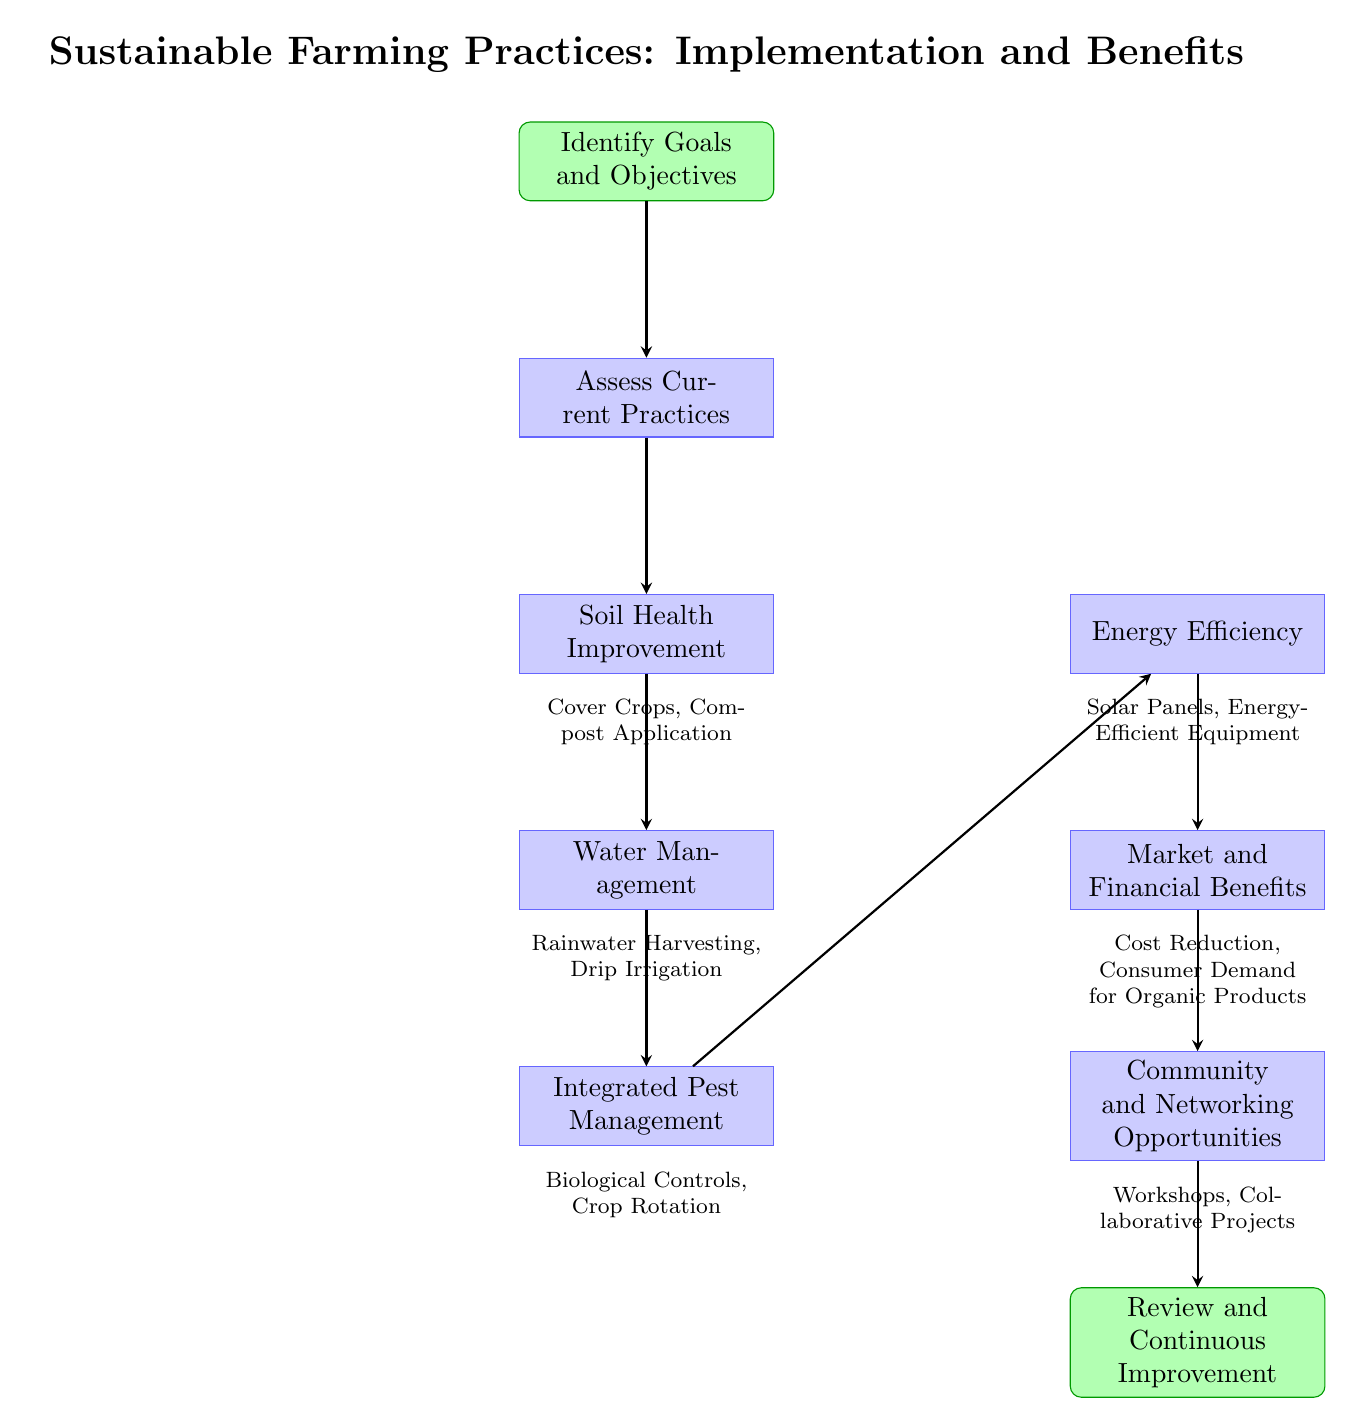What is the starting point of the flow chart? The starting point is clearly labeled in the diagram as "Identify Goals and Objectives." Therefore, it can be found at the topmost position of the flow chart.
Answer: Identify Goals and Objectives What are the two practices listed under Soil Health Improvement? Under the node labeled "Soil Health Improvement," there are two details provided. They are listed as "Cover Crops" and "Compost Application."
Answer: Cover Crops, Compost Application What is the last step in the flow chart? The flow diagram ends with the node labeled "Review and Continuous Improvement," which indicates the concluding step of the outlined process.
Answer: Review and Continuous Improvement How many main processes are there after assessing current practices? From the node "Assess Current Practices," there are five subsequent processes that are detailed in the diagram: "Soil Health Improvement," "Water Management," "Integrated Pest Management," "Energy Efficiency," and "Market and Financial Benefits." Counting these gives us a total of five processes.
Answer: 5 What are the benefits of Market and Financial Benefits? The node labeled "Market and Financial Benefits" includes details about the benefits, specifically "Cost Reduction" and "Consumer Demand for Organic Products." These are the listed advantages in this part of the flow chart.
Answer: Cost Reduction, Consumer Demand for Organic Products What type of projects are indicated under Community and Networking Opportunities? This node highlights that community and networking opportunities can involve "Workshops" and "Collaborative Projects," as detailed in the flow chart. These activities can help to enhance networking in the community.
Answer: Workshops, Collaborative Projects Which two water management practices are mentioned? In the "Water Management" node, the practices listed are "Rainwater Harvesting" and "Drip Irrigation." These practices aim to improve water efficiency in farming.
Answer: Rainwater Harvesting, Drip Irrigation How are Integrated Pest Management practices categorized in the flow chart? The "Integrated Pest Management" node lists specific practices that fall under this category. These practices include "Biological Controls" and "Crop Rotation," which aim to manage pests sustainably.
Answer: Biological Controls, Crop Rotation 